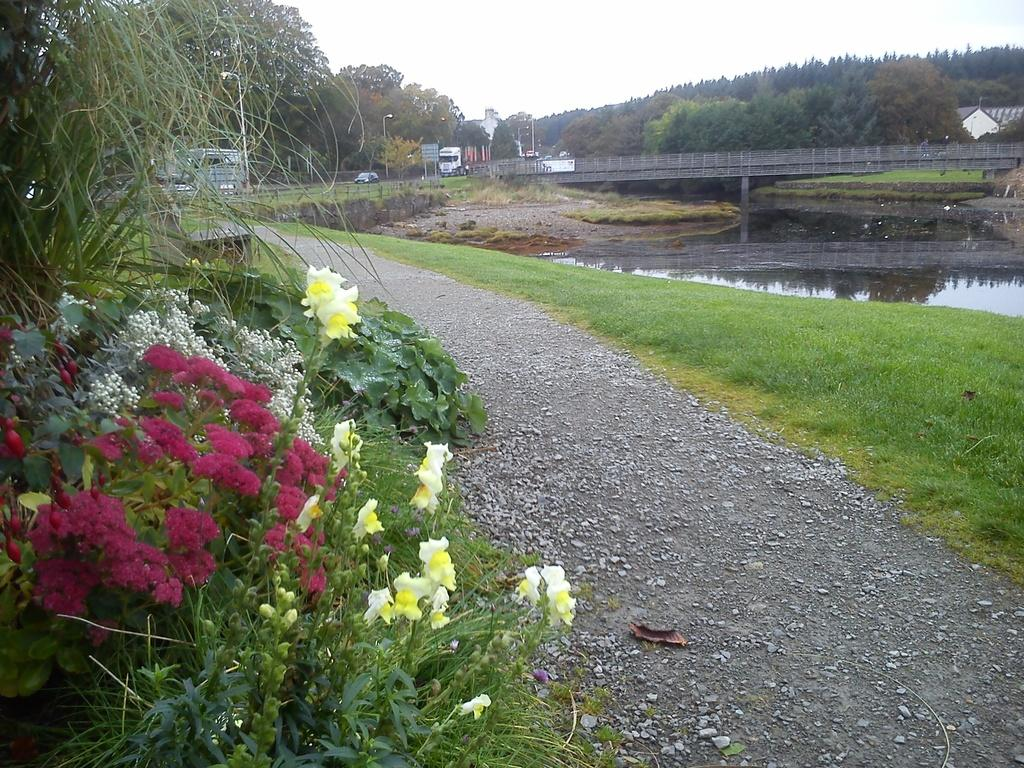What type of vegetation can be seen in the image? There are flowers, plants, and grass visible in the image. What is the water feature in the image? There is water visible in the image. What structures can be seen in the background of the image? There is a bridge and vehicles visible in the background of the image. What else is present in the background of the image? There are trees and the sky visible in the background of the image. Can you tell me how many nails are holding the giraffe up in the image? There is no giraffe present in the image, so there are no nails holding it up. What type of wax is being used to create the flowers in the image? The flowers in the image are real, and there is no wax used to create them. 